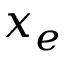Convert formula to latex. <formula><loc_0><loc_0><loc_500><loc_500>x _ { e }</formula> 